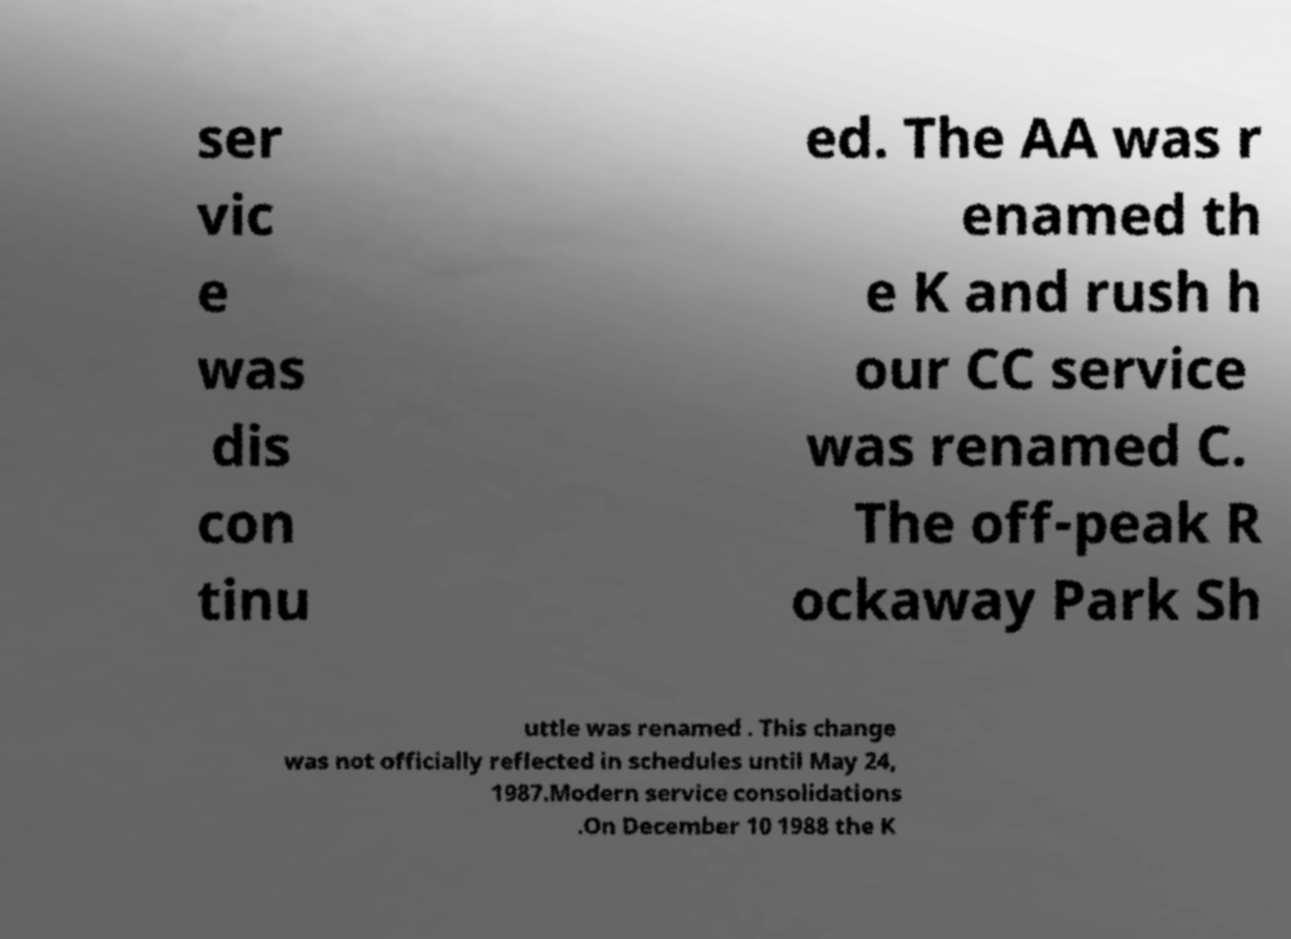Please read and relay the text visible in this image. What does it say? ser vic e was dis con tinu ed. The AA was r enamed th e K and rush h our CC service was renamed C. The off-peak R ockaway Park Sh uttle was renamed . This change was not officially reflected in schedules until May 24, 1987.Modern service consolidations .On December 10 1988 the K 